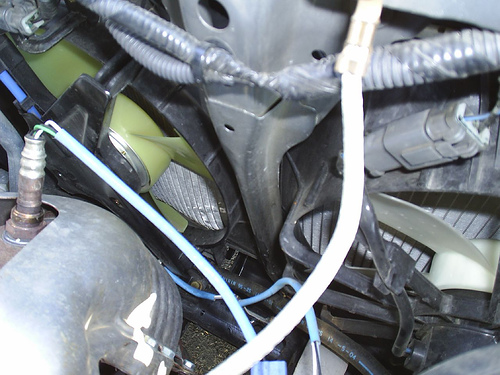<image>
Is there a wires in front of the fan? Yes. The wires is positioned in front of the fan, appearing closer to the camera viewpoint. 